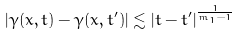<formula> <loc_0><loc_0><loc_500><loc_500>| \gamma ( x , t ) - \gamma ( x , t ^ { \prime } ) | \lesssim | t - t ^ { \prime } | ^ { \frac { 1 } { m _ { 1 } - 1 } }</formula> 